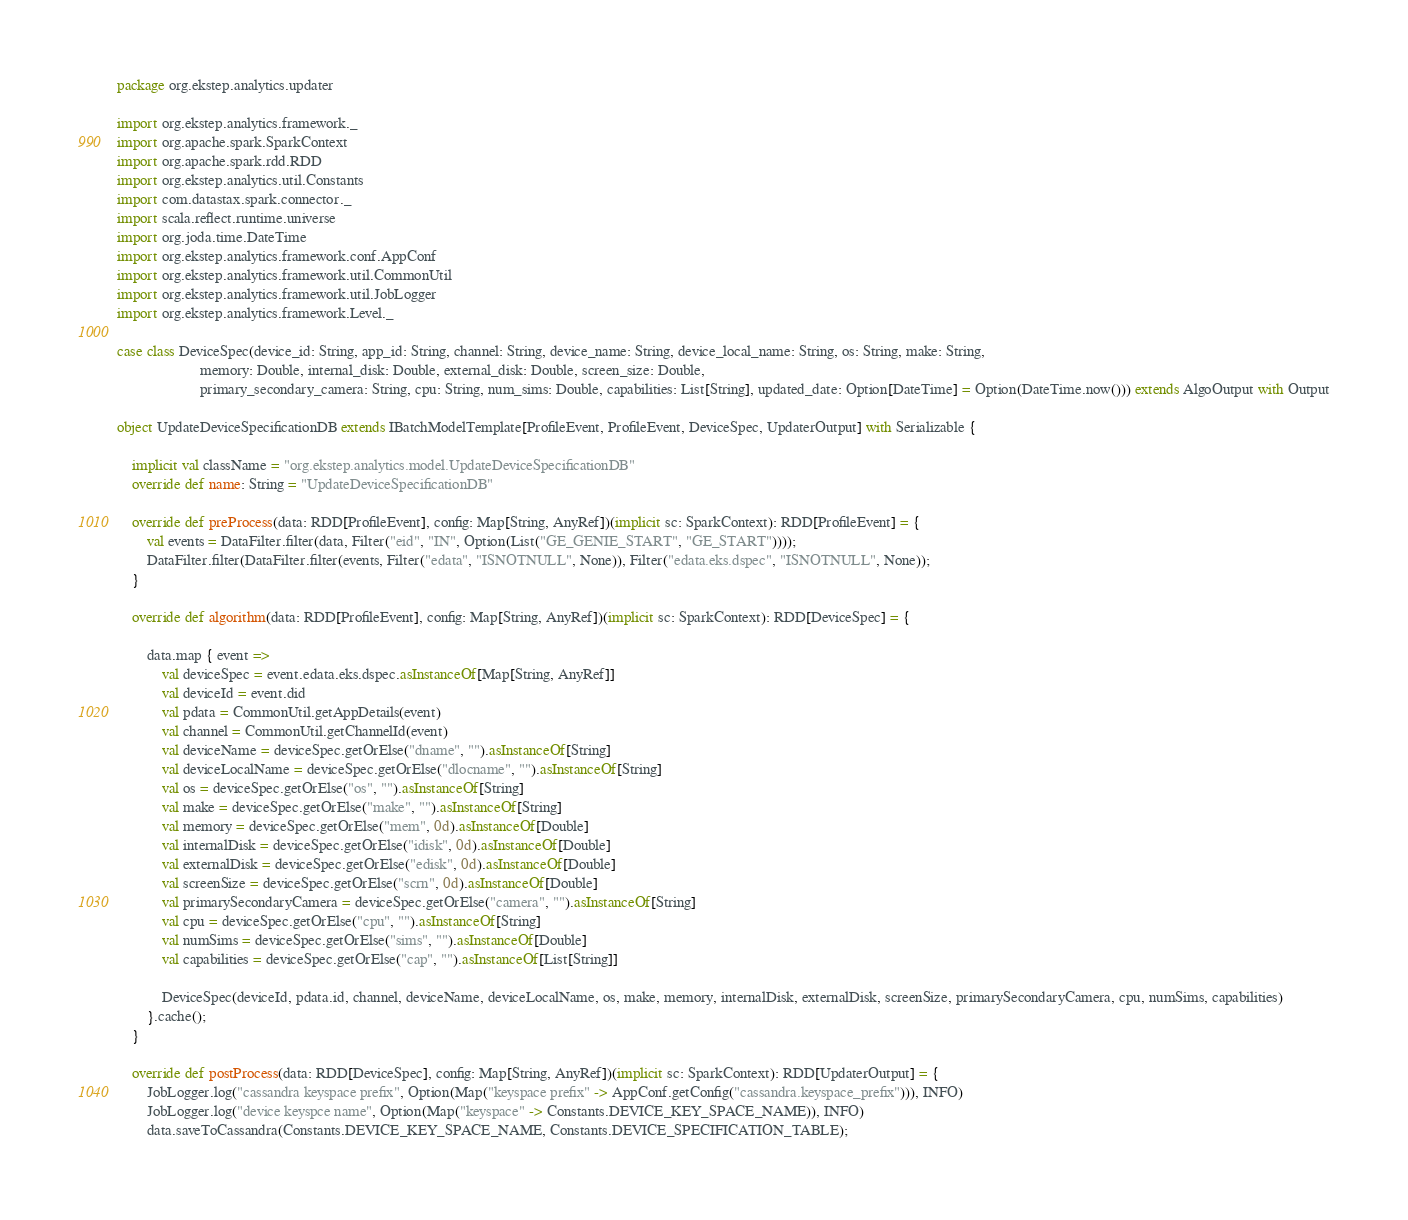Convert code to text. <code><loc_0><loc_0><loc_500><loc_500><_Scala_>package org.ekstep.analytics.updater

import org.ekstep.analytics.framework._
import org.apache.spark.SparkContext
import org.apache.spark.rdd.RDD
import org.ekstep.analytics.util.Constants
import com.datastax.spark.connector._
import scala.reflect.runtime.universe
import org.joda.time.DateTime
import org.ekstep.analytics.framework.conf.AppConf
import org.ekstep.analytics.framework.util.CommonUtil
import org.ekstep.analytics.framework.util.JobLogger
import org.ekstep.analytics.framework.Level._

case class DeviceSpec(device_id: String, app_id: String, channel: String, device_name: String, device_local_name: String, os: String, make: String,
                      memory: Double, internal_disk: Double, external_disk: Double, screen_size: Double,
                      primary_secondary_camera: String, cpu: String, num_sims: Double, capabilities: List[String], updated_date: Option[DateTime] = Option(DateTime.now())) extends AlgoOutput with Output

object UpdateDeviceSpecificationDB extends IBatchModelTemplate[ProfileEvent, ProfileEvent, DeviceSpec, UpdaterOutput] with Serializable {

    implicit val className = "org.ekstep.analytics.model.UpdateDeviceSpecificationDB"
    override def name: String = "UpdateDeviceSpecificationDB"

    override def preProcess(data: RDD[ProfileEvent], config: Map[String, AnyRef])(implicit sc: SparkContext): RDD[ProfileEvent] = {
        val events = DataFilter.filter(data, Filter("eid", "IN", Option(List("GE_GENIE_START", "GE_START"))));
        DataFilter.filter(DataFilter.filter(events, Filter("edata", "ISNOTNULL", None)), Filter("edata.eks.dspec", "ISNOTNULL", None));
    }

    override def algorithm(data: RDD[ProfileEvent], config: Map[String, AnyRef])(implicit sc: SparkContext): RDD[DeviceSpec] = {

        data.map { event =>
            val deviceSpec = event.edata.eks.dspec.asInstanceOf[Map[String, AnyRef]]
            val deviceId = event.did
            val pdata = CommonUtil.getAppDetails(event)
            val channel = CommonUtil.getChannelId(event)
            val deviceName = deviceSpec.getOrElse("dname", "").asInstanceOf[String]
            val deviceLocalName = deviceSpec.getOrElse("dlocname", "").asInstanceOf[String]
            val os = deviceSpec.getOrElse("os", "").asInstanceOf[String]
            val make = deviceSpec.getOrElse("make", "").asInstanceOf[String]
            val memory = deviceSpec.getOrElse("mem", 0d).asInstanceOf[Double]
            val internalDisk = deviceSpec.getOrElse("idisk", 0d).asInstanceOf[Double]
            val externalDisk = deviceSpec.getOrElse("edisk", 0d).asInstanceOf[Double]
            val screenSize = deviceSpec.getOrElse("scrn", 0d).asInstanceOf[Double]
            val primarySecondaryCamera = deviceSpec.getOrElse("camera", "").asInstanceOf[String]
            val cpu = deviceSpec.getOrElse("cpu", "").asInstanceOf[String]
            val numSims = deviceSpec.getOrElse("sims", "").asInstanceOf[Double]
            val capabilities = deviceSpec.getOrElse("cap", "").asInstanceOf[List[String]]

            DeviceSpec(deviceId, pdata.id, channel, deviceName, deviceLocalName, os, make, memory, internalDisk, externalDisk, screenSize, primarySecondaryCamera, cpu, numSims, capabilities)
        }.cache();
    }

    override def postProcess(data: RDD[DeviceSpec], config: Map[String, AnyRef])(implicit sc: SparkContext): RDD[UpdaterOutput] = {
        JobLogger.log("cassandra keyspace prefix", Option(Map("keyspace prefix" -> AppConf.getConfig("cassandra.keyspace_prefix"))), INFO)
        JobLogger.log("device keyspce name", Option(Map("keyspace" -> Constants.DEVICE_KEY_SPACE_NAME)), INFO)
        data.saveToCassandra(Constants.DEVICE_KEY_SPACE_NAME, Constants.DEVICE_SPECIFICATION_TABLE);</code> 